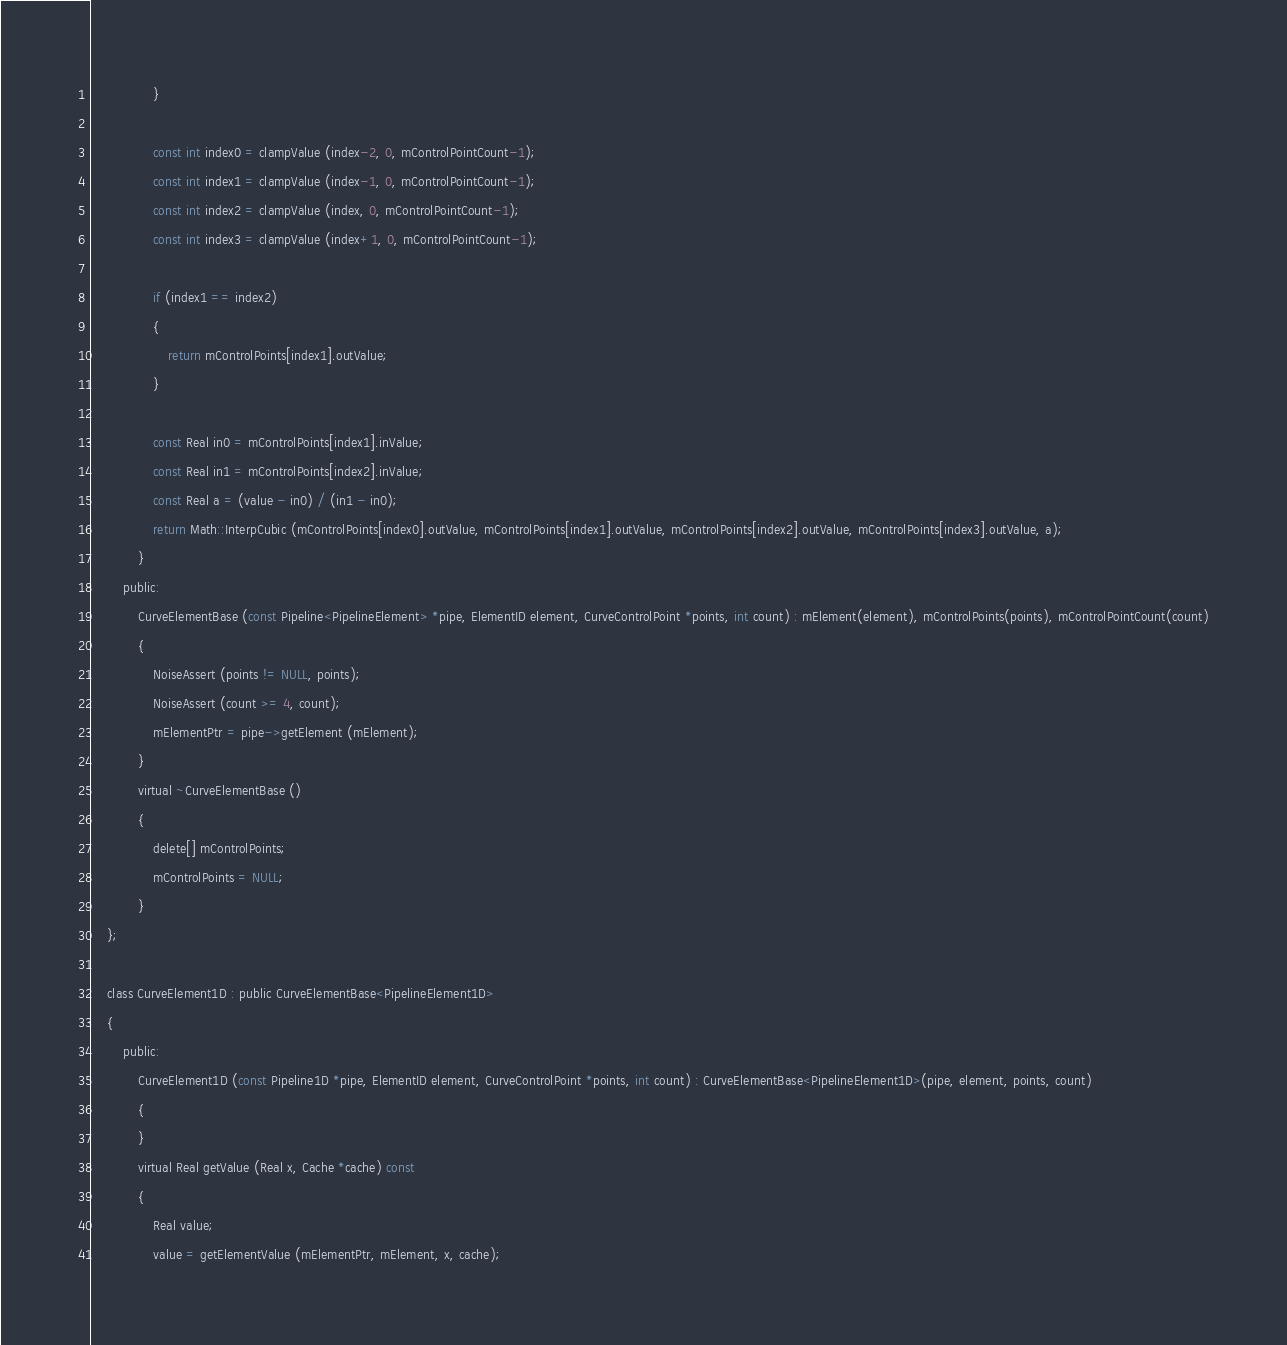<code> <loc_0><loc_0><loc_500><loc_500><_C_>				}

				const int index0 = clampValue (index-2, 0, mControlPointCount-1);
				const int index1 = clampValue (index-1, 0, mControlPointCount-1);
				const int index2 = clampValue (index, 0, mControlPointCount-1);
				const int index3 = clampValue (index+1, 0, mControlPointCount-1);

				if (index1 == index2)
				{
					return mControlPoints[index1].outValue;
				}

				const Real in0 = mControlPoints[index1].inValue;
				const Real in1 = mControlPoints[index2].inValue;
				const Real a = (value - in0) / (in1 - in0);
				return Math::InterpCubic (mControlPoints[index0].outValue, mControlPoints[index1].outValue, mControlPoints[index2].outValue, mControlPoints[index3].outValue, a);
			}
		public:
			CurveElementBase (const Pipeline<PipelineElement> *pipe, ElementID element, CurveControlPoint *points, int count) : mElement(element), mControlPoints(points), mControlPointCount(count)
			{
				NoiseAssert (points != NULL, points);
				NoiseAssert (count >= 4, count);
				mElementPtr = pipe->getElement (mElement);
			}
			virtual ~CurveElementBase ()
			{
				delete[] mControlPoints;
				mControlPoints = NULL;
			}
	};

	class CurveElement1D : public CurveElementBase<PipelineElement1D>
	{
		public:
			CurveElement1D (const Pipeline1D *pipe, ElementID element, CurveControlPoint *points, int count) : CurveElementBase<PipelineElement1D>(pipe, element, points, count)
			{
			}
			virtual Real getValue (Real x, Cache *cache) const
			{
				Real value;
				value = getElementValue (mElementPtr, mElement, x, cache);</code> 